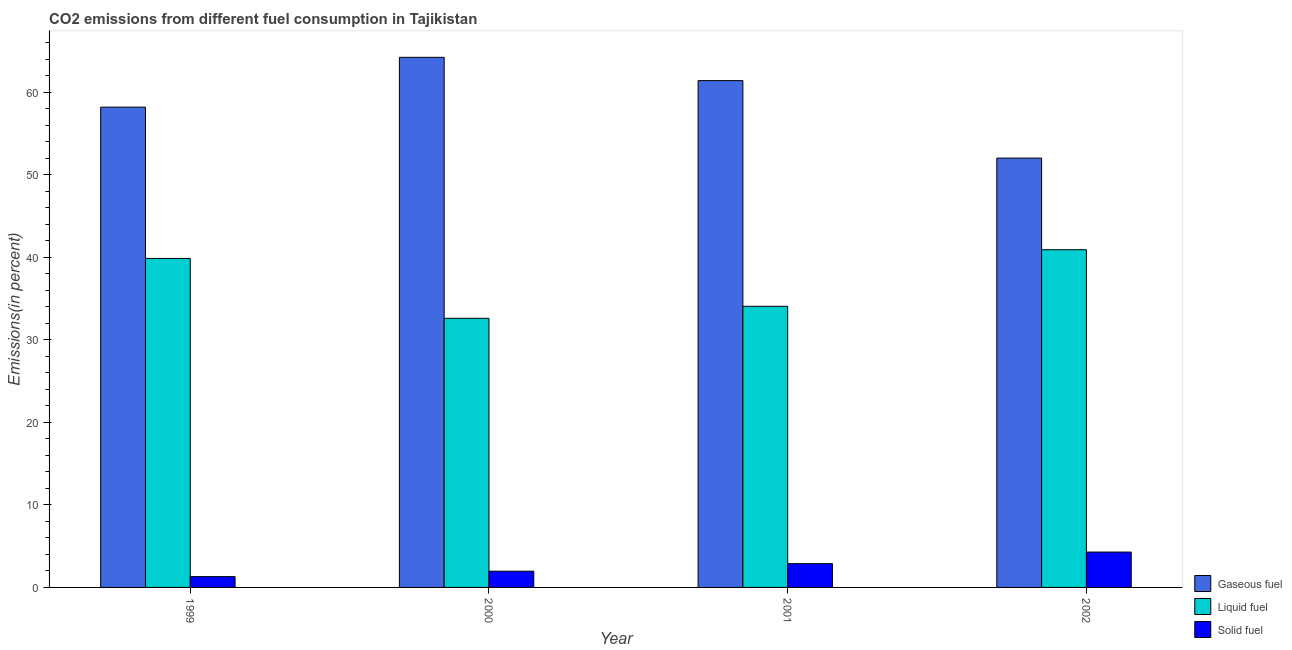How many different coloured bars are there?
Keep it short and to the point. 3. Are the number of bars per tick equal to the number of legend labels?
Ensure brevity in your answer.  Yes. Are the number of bars on each tick of the X-axis equal?
Ensure brevity in your answer.  Yes. How many bars are there on the 1st tick from the left?
Your response must be concise. 3. How many bars are there on the 3rd tick from the right?
Ensure brevity in your answer.  3. What is the percentage of liquid fuel emission in 2000?
Make the answer very short. 32.62. Across all years, what is the maximum percentage of liquid fuel emission?
Give a very brief answer. 40.94. Across all years, what is the minimum percentage of liquid fuel emission?
Give a very brief answer. 32.62. In which year was the percentage of liquid fuel emission maximum?
Make the answer very short. 2002. In which year was the percentage of solid fuel emission minimum?
Offer a very short reply. 1999. What is the total percentage of liquid fuel emission in the graph?
Give a very brief answer. 147.52. What is the difference between the percentage of solid fuel emission in 2000 and that in 2002?
Offer a terse response. -2.32. What is the difference between the percentage of solid fuel emission in 2000 and the percentage of liquid fuel emission in 2001?
Provide a short and direct response. -0.91. What is the average percentage of solid fuel emission per year?
Your answer should be compact. 2.61. In the year 1999, what is the difference between the percentage of liquid fuel emission and percentage of gaseous fuel emission?
Your answer should be very brief. 0. What is the ratio of the percentage of gaseous fuel emission in 1999 to that in 2002?
Give a very brief answer. 1.12. Is the difference between the percentage of liquid fuel emission in 2000 and 2002 greater than the difference between the percentage of gaseous fuel emission in 2000 and 2002?
Ensure brevity in your answer.  No. What is the difference between the highest and the second highest percentage of gaseous fuel emission?
Offer a very short reply. 2.82. What is the difference between the highest and the lowest percentage of gaseous fuel emission?
Your answer should be very brief. 12.22. In how many years, is the percentage of gaseous fuel emission greater than the average percentage of gaseous fuel emission taken over all years?
Provide a short and direct response. 2. Is the sum of the percentage of gaseous fuel emission in 1999 and 2000 greater than the maximum percentage of liquid fuel emission across all years?
Provide a short and direct response. Yes. What does the 2nd bar from the left in 2000 represents?
Offer a terse response. Liquid fuel. What does the 1st bar from the right in 2002 represents?
Provide a succinct answer. Solid fuel. Is it the case that in every year, the sum of the percentage of gaseous fuel emission and percentage of liquid fuel emission is greater than the percentage of solid fuel emission?
Your response must be concise. Yes. How many bars are there?
Keep it short and to the point. 12. Are the values on the major ticks of Y-axis written in scientific E-notation?
Ensure brevity in your answer.  No. Does the graph contain any zero values?
Ensure brevity in your answer.  No. Where does the legend appear in the graph?
Your answer should be very brief. Bottom right. How many legend labels are there?
Offer a terse response. 3. How are the legend labels stacked?
Keep it short and to the point. Vertical. What is the title of the graph?
Your answer should be very brief. CO2 emissions from different fuel consumption in Tajikistan. What is the label or title of the Y-axis?
Your answer should be compact. Emissions(in percent). What is the Emissions(in percent) of Gaseous fuel in 1999?
Provide a short and direct response. 58.22. What is the Emissions(in percent) of Liquid fuel in 1999?
Make the answer very short. 39.88. What is the Emissions(in percent) of Solid fuel in 1999?
Your answer should be compact. 1.31. What is the Emissions(in percent) of Gaseous fuel in 2000?
Offer a very short reply. 64.26. What is the Emissions(in percent) of Liquid fuel in 2000?
Your answer should be very brief. 32.62. What is the Emissions(in percent) in Solid fuel in 2000?
Your response must be concise. 1.97. What is the Emissions(in percent) of Gaseous fuel in 2001?
Your answer should be very brief. 61.44. What is the Emissions(in percent) of Liquid fuel in 2001?
Offer a terse response. 34.08. What is the Emissions(in percent) in Solid fuel in 2001?
Your response must be concise. 2.88. What is the Emissions(in percent) of Gaseous fuel in 2002?
Keep it short and to the point. 52.05. What is the Emissions(in percent) of Liquid fuel in 2002?
Give a very brief answer. 40.94. What is the Emissions(in percent) in Solid fuel in 2002?
Your answer should be very brief. 4.29. Across all years, what is the maximum Emissions(in percent) in Gaseous fuel?
Your response must be concise. 64.26. Across all years, what is the maximum Emissions(in percent) of Liquid fuel?
Offer a terse response. 40.94. Across all years, what is the maximum Emissions(in percent) of Solid fuel?
Keep it short and to the point. 4.29. Across all years, what is the minimum Emissions(in percent) in Gaseous fuel?
Provide a succinct answer. 52.05. Across all years, what is the minimum Emissions(in percent) of Liquid fuel?
Give a very brief answer. 32.62. Across all years, what is the minimum Emissions(in percent) of Solid fuel?
Provide a short and direct response. 1.31. What is the total Emissions(in percent) of Gaseous fuel in the graph?
Ensure brevity in your answer.  235.97. What is the total Emissions(in percent) in Liquid fuel in the graph?
Provide a short and direct response. 147.52. What is the total Emissions(in percent) in Solid fuel in the graph?
Keep it short and to the point. 10.45. What is the difference between the Emissions(in percent) in Gaseous fuel in 1999 and that in 2000?
Provide a succinct answer. -6.04. What is the difference between the Emissions(in percent) of Liquid fuel in 1999 and that in 2000?
Your answer should be compact. 7.26. What is the difference between the Emissions(in percent) in Solid fuel in 1999 and that in 2000?
Your answer should be compact. -0.66. What is the difference between the Emissions(in percent) in Gaseous fuel in 1999 and that in 2001?
Provide a short and direct response. -3.22. What is the difference between the Emissions(in percent) in Liquid fuel in 1999 and that in 2001?
Your answer should be compact. 5.8. What is the difference between the Emissions(in percent) in Solid fuel in 1999 and that in 2001?
Give a very brief answer. -1.57. What is the difference between the Emissions(in percent) of Gaseous fuel in 1999 and that in 2002?
Your response must be concise. 6.18. What is the difference between the Emissions(in percent) in Liquid fuel in 1999 and that in 2002?
Provide a short and direct response. -1.05. What is the difference between the Emissions(in percent) of Solid fuel in 1999 and that in 2002?
Offer a terse response. -2.98. What is the difference between the Emissions(in percent) in Gaseous fuel in 2000 and that in 2001?
Offer a very short reply. 2.82. What is the difference between the Emissions(in percent) in Liquid fuel in 2000 and that in 2001?
Your answer should be very brief. -1.46. What is the difference between the Emissions(in percent) of Solid fuel in 2000 and that in 2001?
Offer a terse response. -0.91. What is the difference between the Emissions(in percent) in Gaseous fuel in 2000 and that in 2002?
Provide a short and direct response. 12.22. What is the difference between the Emissions(in percent) of Liquid fuel in 2000 and that in 2002?
Give a very brief answer. -8.31. What is the difference between the Emissions(in percent) of Solid fuel in 2000 and that in 2002?
Your response must be concise. -2.32. What is the difference between the Emissions(in percent) of Gaseous fuel in 2001 and that in 2002?
Your answer should be very brief. 9.39. What is the difference between the Emissions(in percent) of Liquid fuel in 2001 and that in 2002?
Your answer should be compact. -6.86. What is the difference between the Emissions(in percent) in Solid fuel in 2001 and that in 2002?
Provide a short and direct response. -1.41. What is the difference between the Emissions(in percent) in Gaseous fuel in 1999 and the Emissions(in percent) in Liquid fuel in 2000?
Keep it short and to the point. 25.6. What is the difference between the Emissions(in percent) of Gaseous fuel in 1999 and the Emissions(in percent) of Solid fuel in 2000?
Offer a very short reply. 56.26. What is the difference between the Emissions(in percent) of Liquid fuel in 1999 and the Emissions(in percent) of Solid fuel in 2000?
Offer a terse response. 37.92. What is the difference between the Emissions(in percent) of Gaseous fuel in 1999 and the Emissions(in percent) of Liquid fuel in 2001?
Give a very brief answer. 24.14. What is the difference between the Emissions(in percent) of Gaseous fuel in 1999 and the Emissions(in percent) of Solid fuel in 2001?
Keep it short and to the point. 55.34. What is the difference between the Emissions(in percent) of Liquid fuel in 1999 and the Emissions(in percent) of Solid fuel in 2001?
Your response must be concise. 37. What is the difference between the Emissions(in percent) of Gaseous fuel in 1999 and the Emissions(in percent) of Liquid fuel in 2002?
Ensure brevity in your answer.  17.29. What is the difference between the Emissions(in percent) in Gaseous fuel in 1999 and the Emissions(in percent) in Solid fuel in 2002?
Offer a terse response. 53.94. What is the difference between the Emissions(in percent) in Liquid fuel in 1999 and the Emissions(in percent) in Solid fuel in 2002?
Offer a terse response. 35.6. What is the difference between the Emissions(in percent) of Gaseous fuel in 2000 and the Emissions(in percent) of Liquid fuel in 2001?
Your answer should be compact. 30.18. What is the difference between the Emissions(in percent) of Gaseous fuel in 2000 and the Emissions(in percent) of Solid fuel in 2001?
Provide a short and direct response. 61.38. What is the difference between the Emissions(in percent) in Liquid fuel in 2000 and the Emissions(in percent) in Solid fuel in 2001?
Your answer should be very brief. 29.74. What is the difference between the Emissions(in percent) of Gaseous fuel in 2000 and the Emissions(in percent) of Liquid fuel in 2002?
Make the answer very short. 23.33. What is the difference between the Emissions(in percent) of Gaseous fuel in 2000 and the Emissions(in percent) of Solid fuel in 2002?
Ensure brevity in your answer.  59.97. What is the difference between the Emissions(in percent) of Liquid fuel in 2000 and the Emissions(in percent) of Solid fuel in 2002?
Keep it short and to the point. 28.33. What is the difference between the Emissions(in percent) in Gaseous fuel in 2001 and the Emissions(in percent) in Liquid fuel in 2002?
Ensure brevity in your answer.  20.5. What is the difference between the Emissions(in percent) in Gaseous fuel in 2001 and the Emissions(in percent) in Solid fuel in 2002?
Offer a very short reply. 57.15. What is the difference between the Emissions(in percent) in Liquid fuel in 2001 and the Emissions(in percent) in Solid fuel in 2002?
Make the answer very short. 29.79. What is the average Emissions(in percent) in Gaseous fuel per year?
Ensure brevity in your answer.  58.99. What is the average Emissions(in percent) in Liquid fuel per year?
Ensure brevity in your answer.  36.88. What is the average Emissions(in percent) of Solid fuel per year?
Your response must be concise. 2.61. In the year 1999, what is the difference between the Emissions(in percent) of Gaseous fuel and Emissions(in percent) of Liquid fuel?
Ensure brevity in your answer.  18.34. In the year 1999, what is the difference between the Emissions(in percent) in Gaseous fuel and Emissions(in percent) in Solid fuel?
Make the answer very short. 56.91. In the year 1999, what is the difference between the Emissions(in percent) of Liquid fuel and Emissions(in percent) of Solid fuel?
Offer a terse response. 38.57. In the year 2000, what is the difference between the Emissions(in percent) in Gaseous fuel and Emissions(in percent) in Liquid fuel?
Keep it short and to the point. 31.64. In the year 2000, what is the difference between the Emissions(in percent) of Gaseous fuel and Emissions(in percent) of Solid fuel?
Offer a terse response. 62.3. In the year 2000, what is the difference between the Emissions(in percent) in Liquid fuel and Emissions(in percent) in Solid fuel?
Your answer should be very brief. 30.66. In the year 2001, what is the difference between the Emissions(in percent) of Gaseous fuel and Emissions(in percent) of Liquid fuel?
Make the answer very short. 27.36. In the year 2001, what is the difference between the Emissions(in percent) in Gaseous fuel and Emissions(in percent) in Solid fuel?
Make the answer very short. 58.56. In the year 2001, what is the difference between the Emissions(in percent) in Liquid fuel and Emissions(in percent) in Solid fuel?
Your answer should be very brief. 31.2. In the year 2002, what is the difference between the Emissions(in percent) in Gaseous fuel and Emissions(in percent) in Liquid fuel?
Ensure brevity in your answer.  11.11. In the year 2002, what is the difference between the Emissions(in percent) in Gaseous fuel and Emissions(in percent) in Solid fuel?
Your response must be concise. 47.76. In the year 2002, what is the difference between the Emissions(in percent) of Liquid fuel and Emissions(in percent) of Solid fuel?
Make the answer very short. 36.65. What is the ratio of the Emissions(in percent) of Gaseous fuel in 1999 to that in 2000?
Keep it short and to the point. 0.91. What is the ratio of the Emissions(in percent) in Liquid fuel in 1999 to that in 2000?
Your answer should be very brief. 1.22. What is the ratio of the Emissions(in percent) of Solid fuel in 1999 to that in 2000?
Provide a succinct answer. 0.67. What is the ratio of the Emissions(in percent) in Gaseous fuel in 1999 to that in 2001?
Your answer should be compact. 0.95. What is the ratio of the Emissions(in percent) of Liquid fuel in 1999 to that in 2001?
Your response must be concise. 1.17. What is the ratio of the Emissions(in percent) in Solid fuel in 1999 to that in 2001?
Keep it short and to the point. 0.45. What is the ratio of the Emissions(in percent) in Gaseous fuel in 1999 to that in 2002?
Provide a succinct answer. 1.12. What is the ratio of the Emissions(in percent) of Liquid fuel in 1999 to that in 2002?
Give a very brief answer. 0.97. What is the ratio of the Emissions(in percent) in Solid fuel in 1999 to that in 2002?
Your answer should be very brief. 0.31. What is the ratio of the Emissions(in percent) in Gaseous fuel in 2000 to that in 2001?
Your response must be concise. 1.05. What is the ratio of the Emissions(in percent) of Liquid fuel in 2000 to that in 2001?
Provide a short and direct response. 0.96. What is the ratio of the Emissions(in percent) of Solid fuel in 2000 to that in 2001?
Make the answer very short. 0.68. What is the ratio of the Emissions(in percent) of Gaseous fuel in 2000 to that in 2002?
Make the answer very short. 1.23. What is the ratio of the Emissions(in percent) in Liquid fuel in 2000 to that in 2002?
Your response must be concise. 0.8. What is the ratio of the Emissions(in percent) of Solid fuel in 2000 to that in 2002?
Give a very brief answer. 0.46. What is the ratio of the Emissions(in percent) in Gaseous fuel in 2001 to that in 2002?
Keep it short and to the point. 1.18. What is the ratio of the Emissions(in percent) of Liquid fuel in 2001 to that in 2002?
Keep it short and to the point. 0.83. What is the ratio of the Emissions(in percent) of Solid fuel in 2001 to that in 2002?
Ensure brevity in your answer.  0.67. What is the difference between the highest and the second highest Emissions(in percent) of Gaseous fuel?
Provide a short and direct response. 2.82. What is the difference between the highest and the second highest Emissions(in percent) in Liquid fuel?
Offer a terse response. 1.05. What is the difference between the highest and the second highest Emissions(in percent) of Solid fuel?
Your answer should be compact. 1.41. What is the difference between the highest and the lowest Emissions(in percent) of Gaseous fuel?
Ensure brevity in your answer.  12.22. What is the difference between the highest and the lowest Emissions(in percent) of Liquid fuel?
Offer a very short reply. 8.31. What is the difference between the highest and the lowest Emissions(in percent) in Solid fuel?
Ensure brevity in your answer.  2.98. 